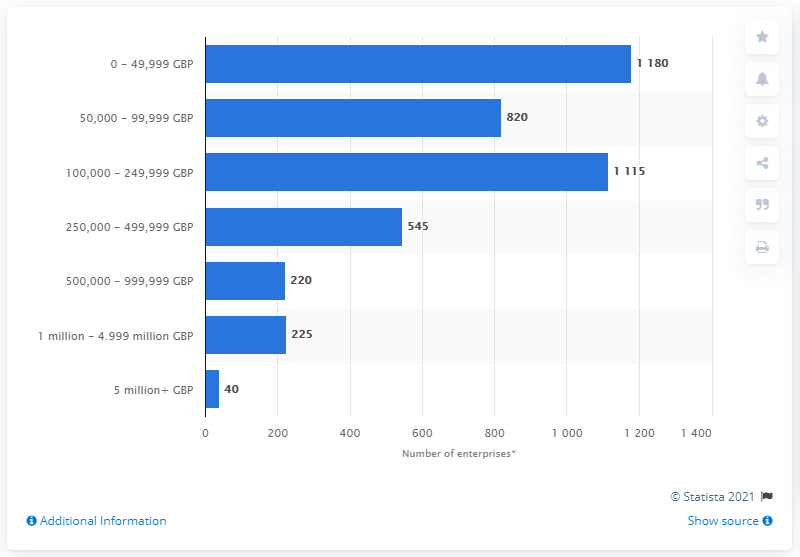Give some essential details in this illustration. As of March 2020, there were approximately 40 enterprises in the fishing and aquaculture industry that had a turnover of more than 5 million GBP. 